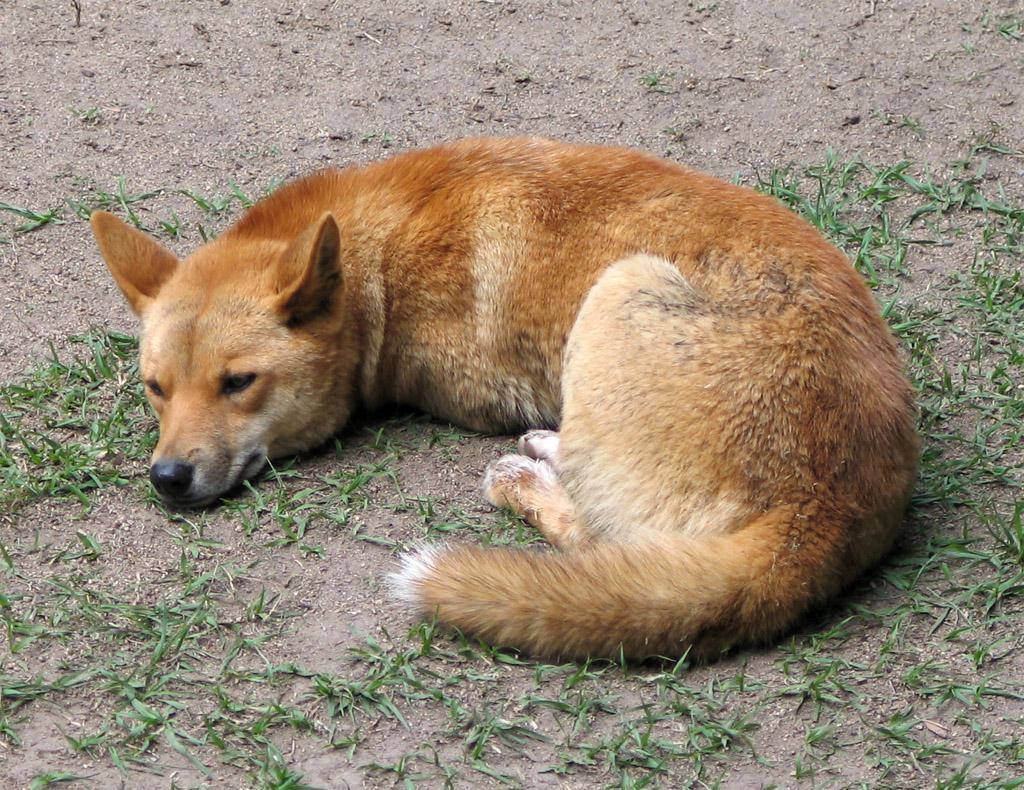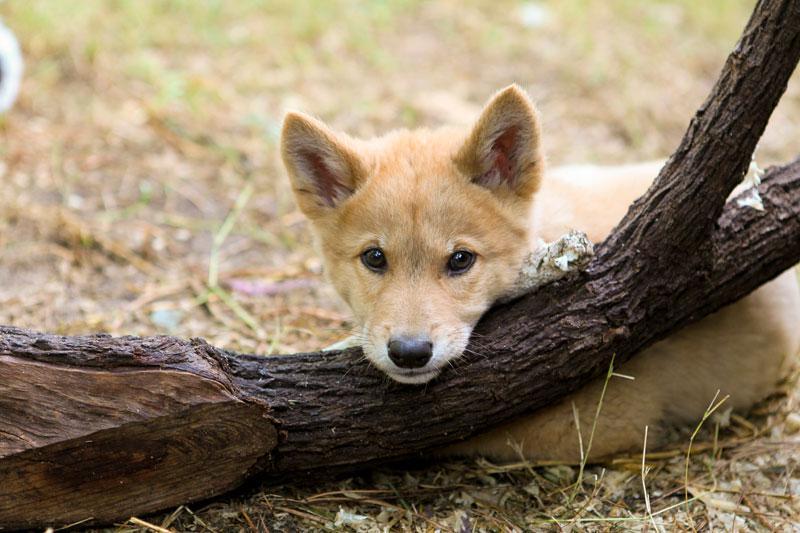The first image is the image on the left, the second image is the image on the right. Given the left and right images, does the statement "One image includes a dingo moving across the sand, and the other image features an adult dingo with its head upon the body of a young dingo." hold true? Answer yes or no. No. The first image is the image on the left, the second image is the image on the right. Given the left and right images, does the statement "The right image contains two wild dogs." hold true? Answer yes or no. No. 